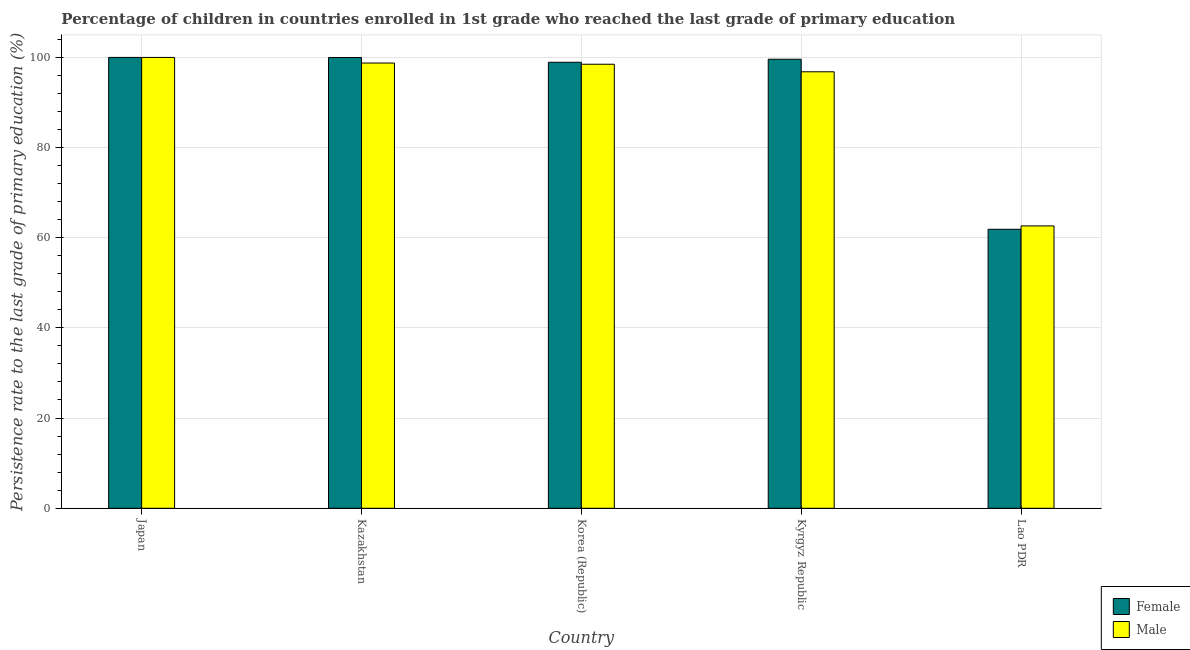How many groups of bars are there?
Give a very brief answer. 5. Are the number of bars on each tick of the X-axis equal?
Give a very brief answer. Yes. In how many cases, is the number of bars for a given country not equal to the number of legend labels?
Make the answer very short. 0. What is the persistence rate of female students in Japan?
Offer a terse response. 99.92. Across all countries, what is the maximum persistence rate of female students?
Give a very brief answer. 99.92. Across all countries, what is the minimum persistence rate of female students?
Offer a terse response. 61.83. In which country was the persistence rate of female students minimum?
Ensure brevity in your answer.  Lao PDR. What is the total persistence rate of female students in the graph?
Provide a succinct answer. 460.01. What is the difference between the persistence rate of female students in Korea (Republic) and that in Lao PDR?
Provide a short and direct response. 37.01. What is the difference between the persistence rate of female students in Japan and the persistence rate of male students in Kyrgyz Republic?
Your answer should be very brief. 3.18. What is the average persistence rate of female students per country?
Make the answer very short. 92. What is the difference between the persistence rate of female students and persistence rate of male students in Kyrgyz Republic?
Your response must be concise. 2.78. What is the ratio of the persistence rate of female students in Kazakhstan to that in Lao PDR?
Your answer should be very brief. 1.62. Is the persistence rate of female students in Japan less than that in Kazakhstan?
Your answer should be very brief. No. Is the difference between the persistence rate of female students in Kyrgyz Republic and Lao PDR greater than the difference between the persistence rate of male students in Kyrgyz Republic and Lao PDR?
Offer a terse response. Yes. What is the difference between the highest and the second highest persistence rate of male students?
Give a very brief answer. 1.24. What is the difference between the highest and the lowest persistence rate of female students?
Your response must be concise. 38.09. In how many countries, is the persistence rate of male students greater than the average persistence rate of male students taken over all countries?
Provide a short and direct response. 4. How many bars are there?
Offer a terse response. 10. How many countries are there in the graph?
Offer a terse response. 5. Are the values on the major ticks of Y-axis written in scientific E-notation?
Your answer should be compact. No. Does the graph contain grids?
Provide a succinct answer. Yes. How many legend labels are there?
Provide a short and direct response. 2. What is the title of the graph?
Offer a terse response. Percentage of children in countries enrolled in 1st grade who reached the last grade of primary education. What is the label or title of the Y-axis?
Provide a succinct answer. Persistence rate to the last grade of primary education (%). What is the Persistence rate to the last grade of primary education (%) in Female in Japan?
Provide a short and direct response. 99.92. What is the Persistence rate to the last grade of primary education (%) of Male in Japan?
Your answer should be compact. 99.92. What is the Persistence rate to the last grade of primary education (%) in Female in Kazakhstan?
Ensure brevity in your answer.  99.9. What is the Persistence rate to the last grade of primary education (%) in Male in Kazakhstan?
Your answer should be compact. 98.67. What is the Persistence rate to the last grade of primary education (%) in Female in Korea (Republic)?
Your answer should be very brief. 98.84. What is the Persistence rate to the last grade of primary education (%) in Male in Korea (Republic)?
Your answer should be very brief. 98.41. What is the Persistence rate to the last grade of primary education (%) of Female in Kyrgyz Republic?
Provide a short and direct response. 99.52. What is the Persistence rate to the last grade of primary education (%) of Male in Kyrgyz Republic?
Ensure brevity in your answer.  96.74. What is the Persistence rate to the last grade of primary education (%) of Female in Lao PDR?
Give a very brief answer. 61.83. What is the Persistence rate to the last grade of primary education (%) of Male in Lao PDR?
Give a very brief answer. 62.58. Across all countries, what is the maximum Persistence rate to the last grade of primary education (%) of Female?
Offer a terse response. 99.92. Across all countries, what is the maximum Persistence rate to the last grade of primary education (%) of Male?
Offer a very short reply. 99.92. Across all countries, what is the minimum Persistence rate to the last grade of primary education (%) in Female?
Offer a very short reply. 61.83. Across all countries, what is the minimum Persistence rate to the last grade of primary education (%) in Male?
Provide a short and direct response. 62.58. What is the total Persistence rate to the last grade of primary education (%) in Female in the graph?
Give a very brief answer. 460.01. What is the total Persistence rate to the last grade of primary education (%) in Male in the graph?
Provide a succinct answer. 456.31. What is the difference between the Persistence rate to the last grade of primary education (%) in Female in Japan and that in Kazakhstan?
Provide a succinct answer. 0.02. What is the difference between the Persistence rate to the last grade of primary education (%) of Male in Japan and that in Kazakhstan?
Your answer should be compact. 1.24. What is the difference between the Persistence rate to the last grade of primary education (%) of Female in Japan and that in Korea (Republic)?
Provide a short and direct response. 1.08. What is the difference between the Persistence rate to the last grade of primary education (%) in Male in Japan and that in Korea (Republic)?
Your answer should be very brief. 1.51. What is the difference between the Persistence rate to the last grade of primary education (%) of Female in Japan and that in Kyrgyz Republic?
Your answer should be compact. 0.41. What is the difference between the Persistence rate to the last grade of primary education (%) of Male in Japan and that in Kyrgyz Republic?
Make the answer very short. 3.18. What is the difference between the Persistence rate to the last grade of primary education (%) of Female in Japan and that in Lao PDR?
Keep it short and to the point. 38.09. What is the difference between the Persistence rate to the last grade of primary education (%) in Male in Japan and that in Lao PDR?
Provide a succinct answer. 37.34. What is the difference between the Persistence rate to the last grade of primary education (%) in Female in Kazakhstan and that in Korea (Republic)?
Ensure brevity in your answer.  1.05. What is the difference between the Persistence rate to the last grade of primary education (%) of Male in Kazakhstan and that in Korea (Republic)?
Offer a very short reply. 0.27. What is the difference between the Persistence rate to the last grade of primary education (%) in Female in Kazakhstan and that in Kyrgyz Republic?
Ensure brevity in your answer.  0.38. What is the difference between the Persistence rate to the last grade of primary education (%) in Male in Kazakhstan and that in Kyrgyz Republic?
Your response must be concise. 1.94. What is the difference between the Persistence rate to the last grade of primary education (%) in Female in Kazakhstan and that in Lao PDR?
Your answer should be very brief. 38.07. What is the difference between the Persistence rate to the last grade of primary education (%) of Male in Kazakhstan and that in Lao PDR?
Provide a short and direct response. 36.1. What is the difference between the Persistence rate to the last grade of primary education (%) in Female in Korea (Republic) and that in Kyrgyz Republic?
Your response must be concise. -0.67. What is the difference between the Persistence rate to the last grade of primary education (%) in Male in Korea (Republic) and that in Kyrgyz Republic?
Your answer should be compact. 1.67. What is the difference between the Persistence rate to the last grade of primary education (%) in Female in Korea (Republic) and that in Lao PDR?
Your response must be concise. 37.01. What is the difference between the Persistence rate to the last grade of primary education (%) of Male in Korea (Republic) and that in Lao PDR?
Your response must be concise. 35.83. What is the difference between the Persistence rate to the last grade of primary education (%) of Female in Kyrgyz Republic and that in Lao PDR?
Offer a very short reply. 37.68. What is the difference between the Persistence rate to the last grade of primary education (%) of Male in Kyrgyz Republic and that in Lao PDR?
Offer a terse response. 34.16. What is the difference between the Persistence rate to the last grade of primary education (%) in Female in Japan and the Persistence rate to the last grade of primary education (%) in Male in Kazakhstan?
Offer a very short reply. 1.25. What is the difference between the Persistence rate to the last grade of primary education (%) of Female in Japan and the Persistence rate to the last grade of primary education (%) of Male in Korea (Republic)?
Your answer should be compact. 1.51. What is the difference between the Persistence rate to the last grade of primary education (%) of Female in Japan and the Persistence rate to the last grade of primary education (%) of Male in Kyrgyz Republic?
Make the answer very short. 3.18. What is the difference between the Persistence rate to the last grade of primary education (%) in Female in Japan and the Persistence rate to the last grade of primary education (%) in Male in Lao PDR?
Make the answer very short. 37.34. What is the difference between the Persistence rate to the last grade of primary education (%) in Female in Kazakhstan and the Persistence rate to the last grade of primary education (%) in Male in Korea (Republic)?
Give a very brief answer. 1.49. What is the difference between the Persistence rate to the last grade of primary education (%) in Female in Kazakhstan and the Persistence rate to the last grade of primary education (%) in Male in Kyrgyz Republic?
Provide a succinct answer. 3.16. What is the difference between the Persistence rate to the last grade of primary education (%) of Female in Kazakhstan and the Persistence rate to the last grade of primary education (%) of Male in Lao PDR?
Your answer should be very brief. 37.32. What is the difference between the Persistence rate to the last grade of primary education (%) of Female in Korea (Republic) and the Persistence rate to the last grade of primary education (%) of Male in Kyrgyz Republic?
Give a very brief answer. 2.11. What is the difference between the Persistence rate to the last grade of primary education (%) in Female in Korea (Republic) and the Persistence rate to the last grade of primary education (%) in Male in Lao PDR?
Give a very brief answer. 36.27. What is the difference between the Persistence rate to the last grade of primary education (%) in Female in Kyrgyz Republic and the Persistence rate to the last grade of primary education (%) in Male in Lao PDR?
Your answer should be compact. 36.94. What is the average Persistence rate to the last grade of primary education (%) in Female per country?
Your answer should be very brief. 92. What is the average Persistence rate to the last grade of primary education (%) in Male per country?
Give a very brief answer. 91.26. What is the difference between the Persistence rate to the last grade of primary education (%) of Female and Persistence rate to the last grade of primary education (%) of Male in Japan?
Ensure brevity in your answer.  0. What is the difference between the Persistence rate to the last grade of primary education (%) in Female and Persistence rate to the last grade of primary education (%) in Male in Kazakhstan?
Provide a short and direct response. 1.23. What is the difference between the Persistence rate to the last grade of primary education (%) in Female and Persistence rate to the last grade of primary education (%) in Male in Korea (Republic)?
Provide a short and direct response. 0.44. What is the difference between the Persistence rate to the last grade of primary education (%) in Female and Persistence rate to the last grade of primary education (%) in Male in Kyrgyz Republic?
Provide a short and direct response. 2.78. What is the difference between the Persistence rate to the last grade of primary education (%) of Female and Persistence rate to the last grade of primary education (%) of Male in Lao PDR?
Give a very brief answer. -0.75. What is the ratio of the Persistence rate to the last grade of primary education (%) of Male in Japan to that in Kazakhstan?
Offer a terse response. 1.01. What is the ratio of the Persistence rate to the last grade of primary education (%) of Female in Japan to that in Korea (Republic)?
Make the answer very short. 1.01. What is the ratio of the Persistence rate to the last grade of primary education (%) in Male in Japan to that in Korea (Republic)?
Provide a succinct answer. 1.02. What is the ratio of the Persistence rate to the last grade of primary education (%) in Female in Japan to that in Kyrgyz Republic?
Give a very brief answer. 1. What is the ratio of the Persistence rate to the last grade of primary education (%) in Male in Japan to that in Kyrgyz Republic?
Make the answer very short. 1.03. What is the ratio of the Persistence rate to the last grade of primary education (%) of Female in Japan to that in Lao PDR?
Your answer should be compact. 1.62. What is the ratio of the Persistence rate to the last grade of primary education (%) in Male in Japan to that in Lao PDR?
Your answer should be compact. 1.6. What is the ratio of the Persistence rate to the last grade of primary education (%) of Female in Kazakhstan to that in Korea (Republic)?
Keep it short and to the point. 1.01. What is the ratio of the Persistence rate to the last grade of primary education (%) of Male in Kazakhstan to that in Kyrgyz Republic?
Give a very brief answer. 1.02. What is the ratio of the Persistence rate to the last grade of primary education (%) of Female in Kazakhstan to that in Lao PDR?
Provide a succinct answer. 1.62. What is the ratio of the Persistence rate to the last grade of primary education (%) in Male in Kazakhstan to that in Lao PDR?
Ensure brevity in your answer.  1.58. What is the ratio of the Persistence rate to the last grade of primary education (%) in Male in Korea (Republic) to that in Kyrgyz Republic?
Keep it short and to the point. 1.02. What is the ratio of the Persistence rate to the last grade of primary education (%) of Female in Korea (Republic) to that in Lao PDR?
Offer a terse response. 1.6. What is the ratio of the Persistence rate to the last grade of primary education (%) of Male in Korea (Republic) to that in Lao PDR?
Provide a succinct answer. 1.57. What is the ratio of the Persistence rate to the last grade of primary education (%) of Female in Kyrgyz Republic to that in Lao PDR?
Provide a succinct answer. 1.61. What is the ratio of the Persistence rate to the last grade of primary education (%) of Male in Kyrgyz Republic to that in Lao PDR?
Offer a terse response. 1.55. What is the difference between the highest and the second highest Persistence rate to the last grade of primary education (%) of Female?
Offer a terse response. 0.02. What is the difference between the highest and the second highest Persistence rate to the last grade of primary education (%) of Male?
Ensure brevity in your answer.  1.24. What is the difference between the highest and the lowest Persistence rate to the last grade of primary education (%) in Female?
Make the answer very short. 38.09. What is the difference between the highest and the lowest Persistence rate to the last grade of primary education (%) in Male?
Keep it short and to the point. 37.34. 